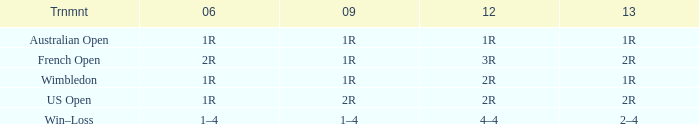What shows for 2006, when 2013 is 2–4? 1–4. 